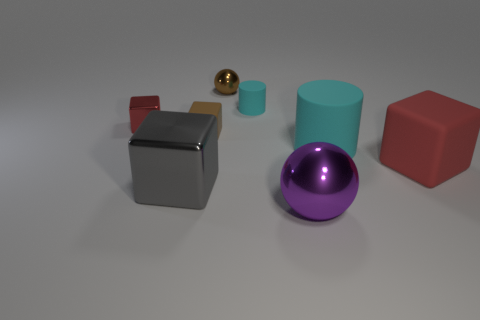Subtract all tiny red metal cubes. How many cubes are left? 3 Subtract all gray cubes. How many cubes are left? 3 Subtract all spheres. How many objects are left? 6 Subtract 3 blocks. How many blocks are left? 1 Add 2 red rubber blocks. How many objects exist? 10 Subtract all green cylinders. Subtract all purple blocks. How many cylinders are left? 2 Subtract all brown cylinders. How many purple spheres are left? 1 Subtract all purple balls. Subtract all small rubber cylinders. How many objects are left? 6 Add 4 tiny matte objects. How many tiny matte objects are left? 6 Add 7 large purple metallic balls. How many large purple metallic balls exist? 8 